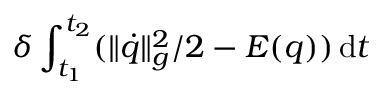Convert formula to latex. <formula><loc_0><loc_0><loc_500><loc_500>\delta \int _ { t _ { 1 } } ^ { t _ { 2 } } ( \| \dot { q } \| _ { g } ^ { 2 } / 2 - E ( q ) ) \, d t</formula> 